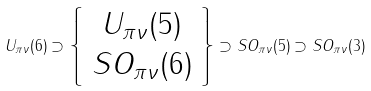Convert formula to latex. <formula><loc_0><loc_0><loc_500><loc_500>U _ { \pi \nu } ( 6 ) \supset \left \{ \begin{array} { c } U _ { \pi \nu } ( 5 ) \\ S O _ { \pi \nu } ( 6 ) \\ \end{array} \right \} \supset S O _ { \pi \nu } ( 5 ) \supset S O _ { \pi \nu } ( 3 )</formula> 